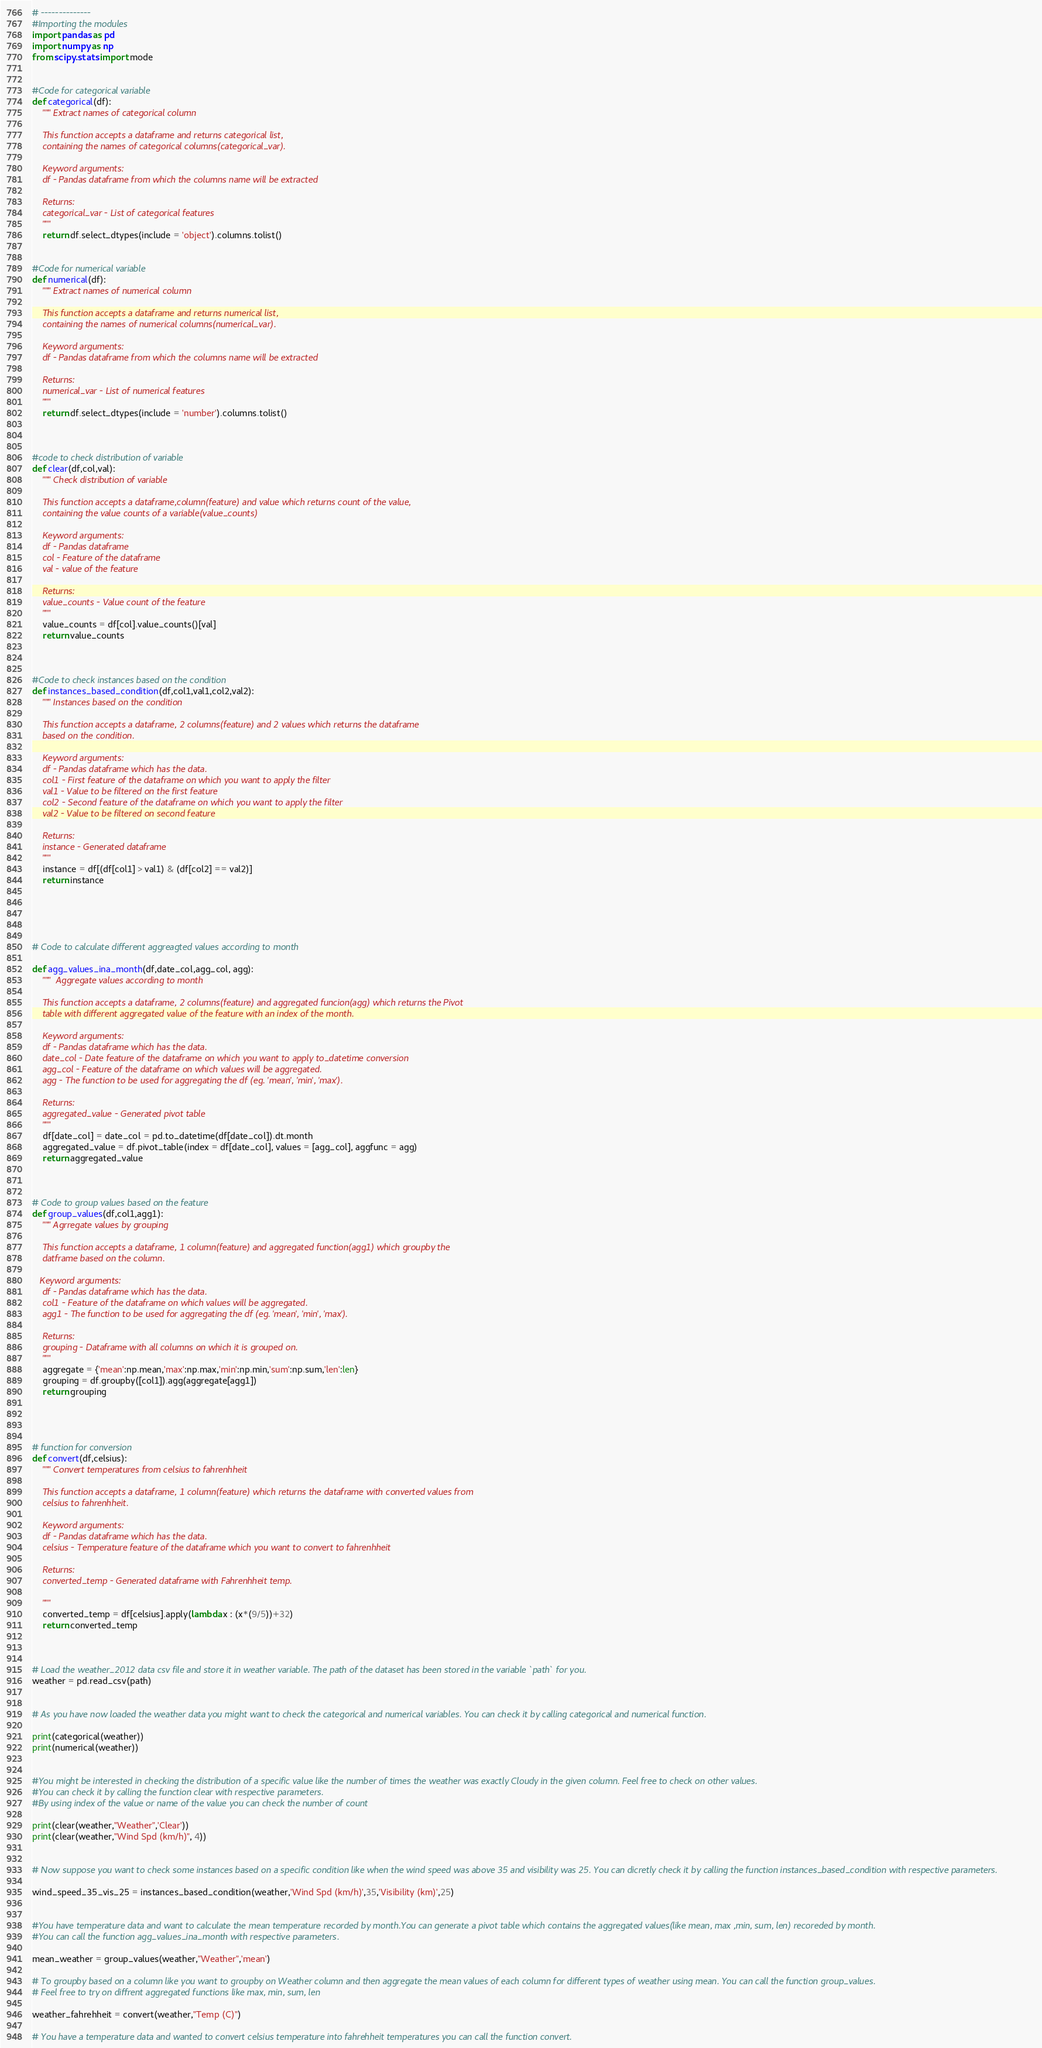<code> <loc_0><loc_0><loc_500><loc_500><_Python_># --------------
#Importing the modules
import pandas as pd
import numpy as np
from scipy.stats import mode 


#Code for categorical variable
def categorical(df):
    """ Extract names of categorical column
    
    This function accepts a dataframe and returns categorical list,
    containing the names of categorical columns(categorical_var).
    
    Keyword arguments:
    df - Pandas dataframe from which the columns name will be extracted
        
    Returns:
    categorical_var - List of categorical features
    """
    return df.select_dtypes(include = 'object').columns.tolist()


#Code for numerical variable
def numerical(df):
    """ Extract names of numerical column
    
    This function accepts a dataframe and returns numerical list,
    containing the names of numerical columns(numerical_var).
        
    Keyword arguments:
    df - Pandas dataframe from which the columns name will be extracted
    
    Returns:
    numerical_var - List of numerical features
    """
    return df.select_dtypes(include = 'number').columns.tolist()



#code to check distribution of variable
def clear(df,col,val):
    """ Check distribution of variable
    
    This function accepts a dataframe,column(feature) and value which returns count of the value,
    containing the value counts of a variable(value_counts)
    
    Keyword arguments:
    df - Pandas dataframe
    col - Feature of the dataframe
    val - value of the feature
    
    Returns:
    value_counts - Value count of the feature 
    """
    value_counts = df[col].value_counts()[val]
    return value_counts



#Code to check instances based on the condition
def instances_based_condition(df,col1,val1,col2,val2):
    """ Instances based on the condition
    
    This function accepts a dataframe, 2 columns(feature) and 2 values which returns the dataframe
    based on the condition.
    
    Keyword arguments:
    df - Pandas dataframe which has the data.
    col1 - First feature of the dataframe on which you want to apply the filter
    val1 - Value to be filtered on the first feature
    col2 - Second feature of the dataframe on which you want to apply the filter
    val2 - Value to be filtered on second feature
    
    Returns:
    instance - Generated dataframe
    """
    instance = df[(df[col1] > val1) & (df[col2] == val2)]
    return instance
    
    



# Code to calculate different aggreagted values according to month

def agg_values_ina_month(df,date_col,agg_col, agg):
    """  Aggregate values according to month
    
    This function accepts a dataframe, 2 columns(feature) and aggregated funcion(agg) which returns the Pivot 
    table with different aggregated value of the feature with an index of the month.
     
    Keyword arguments:
    df - Pandas dataframe which has the data.
    date_col - Date feature of the dataframe on which you want to apply to_datetime conversion
    agg_col - Feature of the dataframe on which values will be aggregated.
    agg - The function to be used for aggregating the df (eg. 'mean', 'min', 'max').
    
    Returns:
    aggregated_value - Generated pivot table
    """
    df[date_col] = date_col = pd.to_datetime(df[date_col]).dt.month
    aggregated_value = df.pivot_table(index = df[date_col], values = [agg_col], aggfunc = agg)
    return aggregated_value



# Code to group values based on the feature
def group_values(df,col1,agg1):
    """ Agrregate values by grouping
    
    This function accepts a dataframe, 1 column(feature) and aggregated function(agg1) which groupby the 
    datframe based on the column.
   
   Keyword arguments:
    df - Pandas dataframe which has the data.
    col1 - Feature of the dataframe on which values will be aggregated.
    agg1 - The function to be used for aggregating the df (eg. 'mean', 'min', 'max').
    
    Returns:
    grouping - Dataframe with all columns on which it is grouped on.
    """
    aggregate = {'mean':np.mean,'max':np.max,'min':np.min,'sum':np.sum,'len':len}
    grouping = df.groupby([col1]).agg(aggregate[agg1]) 
    return grouping
    



# function for conversion 
def convert(df,celsius):
    """ Convert temperatures from celsius to fahrenhheit
    
    This function accepts a dataframe, 1 column(feature) which returns the dataframe with converted values from 
    celsius to fahrenhheit.
         
    Keyword arguments:
    df - Pandas dataframe which has the data.
    celsius - Temperature feature of the dataframe which you want to convert to fahrenhheit
    
    Returns:
    converted_temp - Generated dataframe with Fahrenhheit temp.
    
    """
    converted_temp = df[celsius].apply(lambda x : (x*(9/5))+32)
    return converted_temp
    


# Load the weather_2012 data csv file and store it in weather variable. The path of the dataset has been stored in the variable `path` for you.
weather = pd.read_csv(path)


# As you have now loaded the weather data you might want to check the categorical and numerical variables. You can check it by calling categorical and numerical function. 

print(categorical(weather))
print(numerical(weather))


#You might be interested in checking the distribution of a specific value like the number of times the weather was exactly Cloudy in the given column. Feel free to check on other values.
#You can check it by calling the function clear with respective parameters.
#By using index of the value or name of the value you can check the number of count

print(clear(weather,"Weather",'Clear'))
print(clear(weather,"Wind Spd (km/h)", 4))


# Now suppose you want to check some instances based on a specific condition like when the wind speed was above 35 and visibility was 25. You can dicretly check it by calling the function instances_based_condition with respective parameters.

wind_speed_35_vis_25 = instances_based_condition(weather,'Wind Spd (km/h)',35,'Visibility (km)',25)


#You have temperature data and want to calculate the mean temperature recorded by month.You can generate a pivot table which contains the aggregated values(like mean, max ,min, sum, len) recoreded by month. 
#You can call the function agg_values_ina_month with respective parameters. 

mean_weather = group_values(weather,"Weather",'mean')

# To groupby based on a column like you want to groupby on Weather column and then aggregate the mean values of each column for different types of weather using mean. You can call the function group_values.
# Feel free to try on diffrent aggregated functions like max, min, sum, len

weather_fahrehheit = convert(weather,"Temp (C)")

# You have a temperature data and wanted to convert celsius temperature into fahrehheit temperatures you can call the function convert.


</code> 